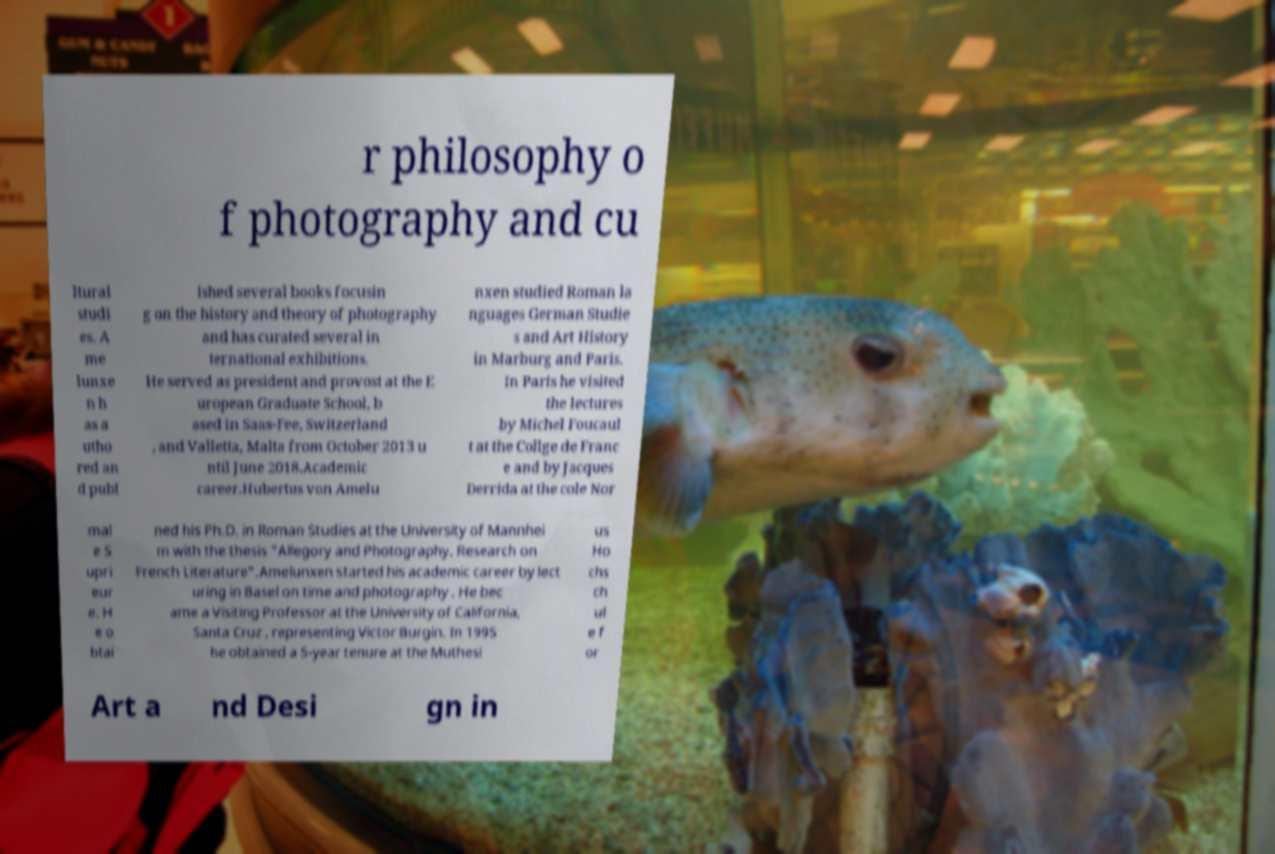Could you extract and type out the text from this image? r philosophy o f photography and cu ltural studi es. A me lunxe n h as a utho red an d publ ished several books focusin g on the history and theory of photography and has curated several in ternational exhibitions. He served as president and provost at the E uropean Graduate School, b ased in Saas-Fee, Switzerland , and Valletta, Malta from October 2013 u ntil June 2018.Academic career.Hubertus von Amelu nxen studied Roman la nguages German Studie s and Art History in Marburg and Paris. In Paris he visited the lectures by Michel Foucaul t at the Collge de Franc e and by Jacques Derrida at the cole Nor mal e S upri eur e. H e o btai ned his Ph.D. in Roman Studies at the University of Mannhei m with the thesis "Allegory and Photography. Research on French Literature".Amelunxen started his academic career by lect uring in Basel on time and photography . He bec ame a Visiting Professor at the University of California, Santa Cruz , representing Victor Burgin. In 1995 he obtained a 5-year tenure at the Muthesi us Ho chs ch ul e f or Art a nd Desi gn in 